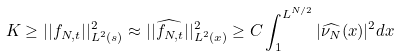Convert formula to latex. <formula><loc_0><loc_0><loc_500><loc_500>K \geq | | f _ { N , t } | | ^ { 2 } _ { L ^ { 2 } ( s ) } \approx | | \widehat { f _ { N , t } } | | ^ { 2 } _ { L ^ { 2 } ( x ) } \geq C \int _ { 1 } ^ { L ^ { N / 2 } } { | \widehat { \nu _ { N } } ( x ) | ^ { 2 } d x }</formula> 